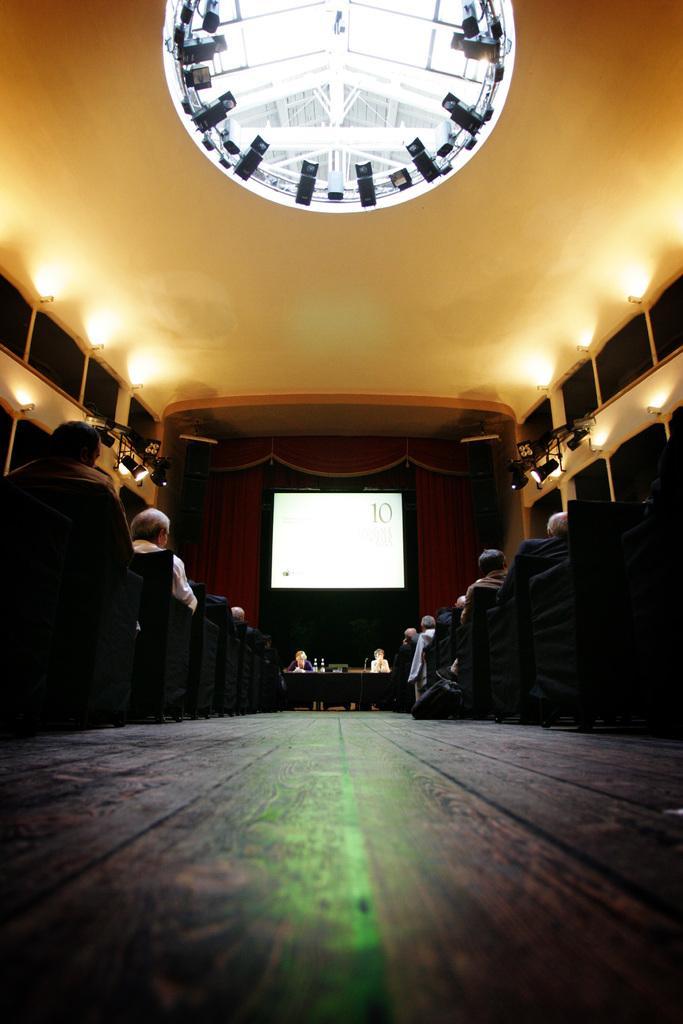Please provide a concise description of this image. This picture describes about group of people, they are seated on the chairs, in the background we can see a projector screen and few lights, and also we can see curtains. 